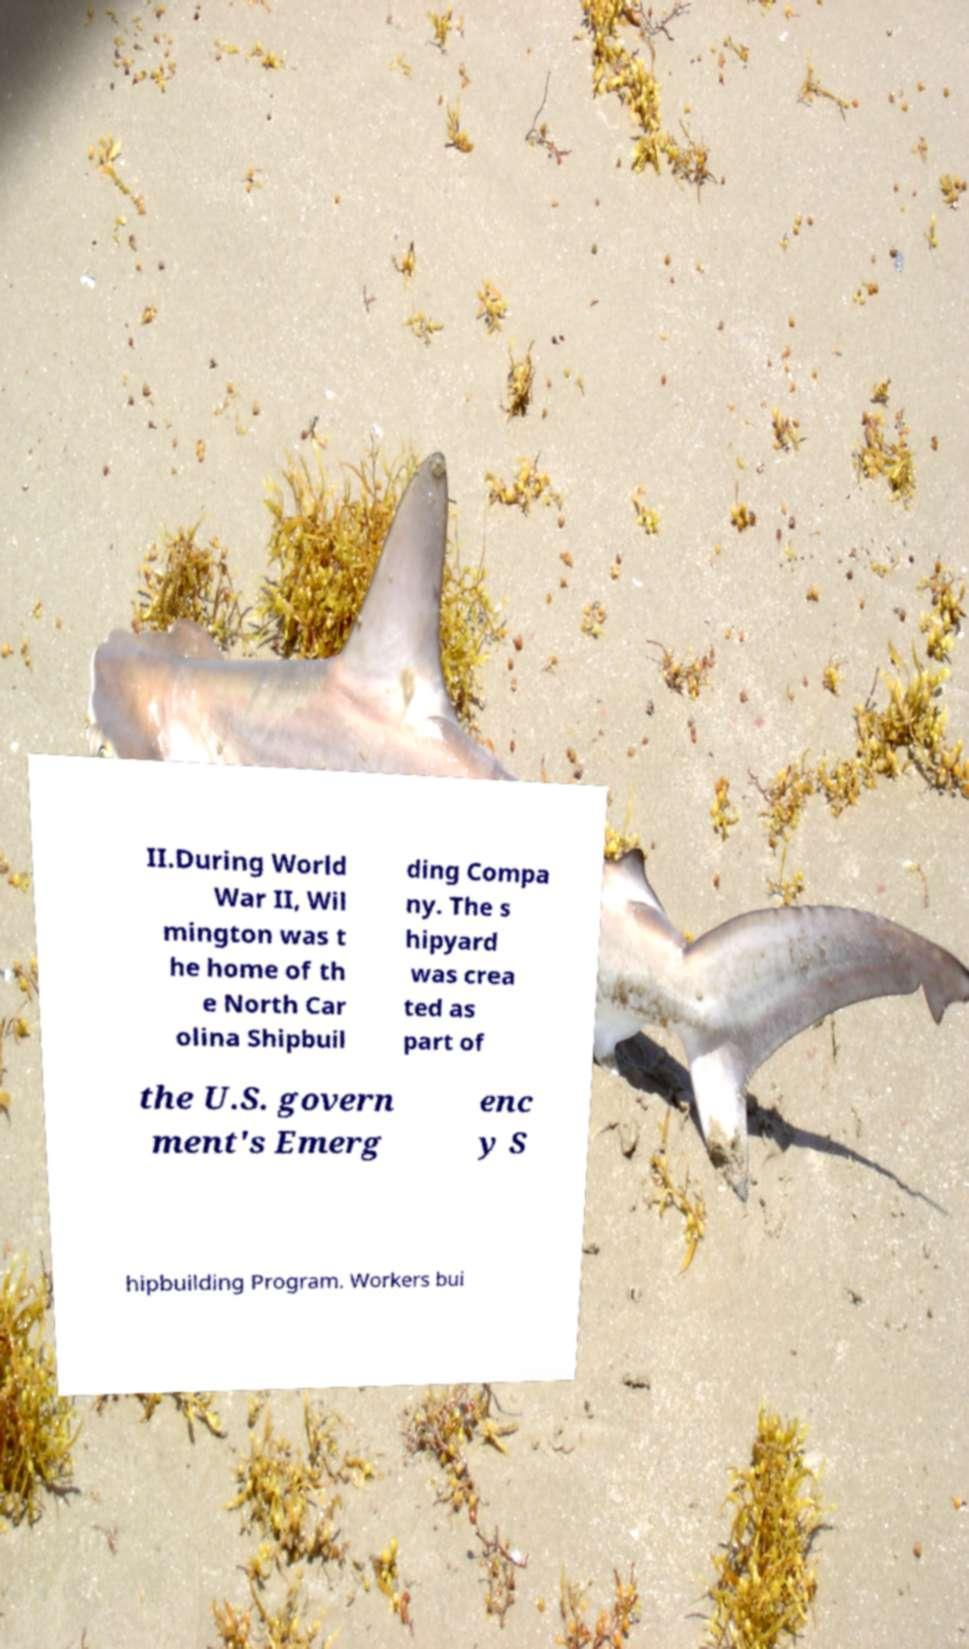There's text embedded in this image that I need extracted. Can you transcribe it verbatim? II.During World War II, Wil mington was t he home of th e North Car olina Shipbuil ding Compa ny. The s hipyard was crea ted as part of the U.S. govern ment's Emerg enc y S hipbuilding Program. Workers bui 